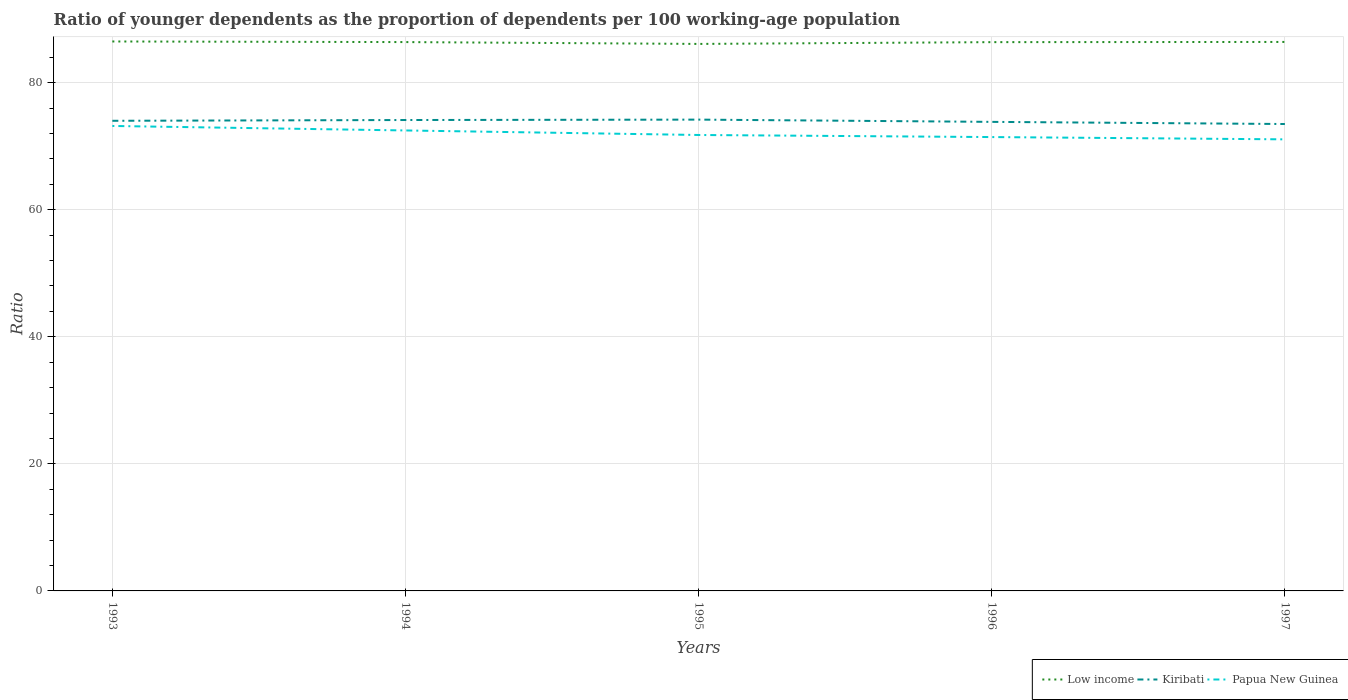Does the line corresponding to Papua New Guinea intersect with the line corresponding to Low income?
Give a very brief answer. No. Across all years, what is the maximum age dependency ratio(young) in Low income?
Make the answer very short. 86.1. What is the total age dependency ratio(young) in Low income in the graph?
Provide a short and direct response. 0.39. What is the difference between the highest and the second highest age dependency ratio(young) in Low income?
Your response must be concise. 0.39. What is the difference between the highest and the lowest age dependency ratio(young) in Kiribati?
Your answer should be very brief. 3. How many lines are there?
Ensure brevity in your answer.  3. How many years are there in the graph?
Make the answer very short. 5. What is the difference between two consecutive major ticks on the Y-axis?
Make the answer very short. 20. Are the values on the major ticks of Y-axis written in scientific E-notation?
Keep it short and to the point. No. Does the graph contain any zero values?
Your answer should be compact. No. Does the graph contain grids?
Your response must be concise. Yes. Where does the legend appear in the graph?
Ensure brevity in your answer.  Bottom right. How many legend labels are there?
Make the answer very short. 3. What is the title of the graph?
Your response must be concise. Ratio of younger dependents as the proportion of dependents per 100 working-age population. What is the label or title of the X-axis?
Make the answer very short. Years. What is the label or title of the Y-axis?
Your response must be concise. Ratio. What is the Ratio in Low income in 1993?
Offer a terse response. 86.49. What is the Ratio of Kiribati in 1993?
Provide a short and direct response. 74. What is the Ratio of Papua New Guinea in 1993?
Your answer should be very brief. 73.19. What is the Ratio in Low income in 1994?
Offer a very short reply. 86.39. What is the Ratio in Kiribati in 1994?
Offer a very short reply. 74.12. What is the Ratio of Papua New Guinea in 1994?
Ensure brevity in your answer.  72.48. What is the Ratio of Low income in 1995?
Your response must be concise. 86.1. What is the Ratio of Kiribati in 1995?
Offer a terse response. 74.19. What is the Ratio in Papua New Guinea in 1995?
Your response must be concise. 71.77. What is the Ratio of Low income in 1996?
Offer a terse response. 86.38. What is the Ratio in Kiribati in 1996?
Give a very brief answer. 73.83. What is the Ratio in Papua New Guinea in 1996?
Keep it short and to the point. 71.44. What is the Ratio in Low income in 1997?
Make the answer very short. 86.41. What is the Ratio of Kiribati in 1997?
Offer a terse response. 73.49. What is the Ratio of Papua New Guinea in 1997?
Offer a terse response. 71.08. Across all years, what is the maximum Ratio of Low income?
Provide a succinct answer. 86.49. Across all years, what is the maximum Ratio in Kiribati?
Offer a very short reply. 74.19. Across all years, what is the maximum Ratio in Papua New Guinea?
Offer a terse response. 73.19. Across all years, what is the minimum Ratio in Low income?
Give a very brief answer. 86.1. Across all years, what is the minimum Ratio of Kiribati?
Offer a very short reply. 73.49. Across all years, what is the minimum Ratio in Papua New Guinea?
Your response must be concise. 71.08. What is the total Ratio in Low income in the graph?
Offer a very short reply. 431.78. What is the total Ratio in Kiribati in the graph?
Your response must be concise. 369.64. What is the total Ratio in Papua New Guinea in the graph?
Your answer should be very brief. 359.96. What is the difference between the Ratio of Low income in 1993 and that in 1994?
Keep it short and to the point. 0.1. What is the difference between the Ratio of Kiribati in 1993 and that in 1994?
Your answer should be very brief. -0.12. What is the difference between the Ratio of Papua New Guinea in 1993 and that in 1994?
Keep it short and to the point. 0.71. What is the difference between the Ratio in Low income in 1993 and that in 1995?
Your answer should be very brief. 0.39. What is the difference between the Ratio of Kiribati in 1993 and that in 1995?
Keep it short and to the point. -0.19. What is the difference between the Ratio of Papua New Guinea in 1993 and that in 1995?
Ensure brevity in your answer.  1.42. What is the difference between the Ratio of Low income in 1993 and that in 1996?
Offer a terse response. 0.11. What is the difference between the Ratio in Kiribati in 1993 and that in 1996?
Give a very brief answer. 0.17. What is the difference between the Ratio of Papua New Guinea in 1993 and that in 1996?
Offer a very short reply. 1.75. What is the difference between the Ratio of Low income in 1993 and that in 1997?
Offer a terse response. 0.07. What is the difference between the Ratio in Kiribati in 1993 and that in 1997?
Your answer should be compact. 0.51. What is the difference between the Ratio of Papua New Guinea in 1993 and that in 1997?
Give a very brief answer. 2.11. What is the difference between the Ratio of Low income in 1994 and that in 1995?
Offer a very short reply. 0.29. What is the difference between the Ratio of Kiribati in 1994 and that in 1995?
Your answer should be compact. -0.06. What is the difference between the Ratio in Papua New Guinea in 1994 and that in 1995?
Ensure brevity in your answer.  0.71. What is the difference between the Ratio of Low income in 1994 and that in 1996?
Give a very brief answer. 0.01. What is the difference between the Ratio of Kiribati in 1994 and that in 1996?
Make the answer very short. 0.29. What is the difference between the Ratio of Papua New Guinea in 1994 and that in 1996?
Offer a terse response. 1.04. What is the difference between the Ratio in Low income in 1994 and that in 1997?
Make the answer very short. -0.02. What is the difference between the Ratio of Kiribati in 1994 and that in 1997?
Your answer should be very brief. 0.63. What is the difference between the Ratio of Papua New Guinea in 1994 and that in 1997?
Offer a terse response. 1.4. What is the difference between the Ratio of Low income in 1995 and that in 1996?
Keep it short and to the point. -0.28. What is the difference between the Ratio in Kiribati in 1995 and that in 1996?
Provide a short and direct response. 0.35. What is the difference between the Ratio of Papua New Guinea in 1995 and that in 1996?
Keep it short and to the point. 0.33. What is the difference between the Ratio in Low income in 1995 and that in 1997?
Your answer should be compact. -0.31. What is the difference between the Ratio in Kiribati in 1995 and that in 1997?
Your answer should be compact. 0.69. What is the difference between the Ratio in Papua New Guinea in 1995 and that in 1997?
Offer a very short reply. 0.69. What is the difference between the Ratio in Low income in 1996 and that in 1997?
Make the answer very short. -0.03. What is the difference between the Ratio of Kiribati in 1996 and that in 1997?
Your answer should be very brief. 0.34. What is the difference between the Ratio of Papua New Guinea in 1996 and that in 1997?
Make the answer very short. 0.36. What is the difference between the Ratio in Low income in 1993 and the Ratio in Kiribati in 1994?
Your response must be concise. 12.36. What is the difference between the Ratio in Low income in 1993 and the Ratio in Papua New Guinea in 1994?
Provide a succinct answer. 14.01. What is the difference between the Ratio in Kiribati in 1993 and the Ratio in Papua New Guinea in 1994?
Offer a terse response. 1.52. What is the difference between the Ratio of Low income in 1993 and the Ratio of Kiribati in 1995?
Provide a short and direct response. 12.3. What is the difference between the Ratio of Low income in 1993 and the Ratio of Papua New Guinea in 1995?
Your answer should be very brief. 14.72. What is the difference between the Ratio in Kiribati in 1993 and the Ratio in Papua New Guinea in 1995?
Make the answer very short. 2.23. What is the difference between the Ratio in Low income in 1993 and the Ratio in Kiribati in 1996?
Your answer should be very brief. 12.66. What is the difference between the Ratio of Low income in 1993 and the Ratio of Papua New Guinea in 1996?
Keep it short and to the point. 15.05. What is the difference between the Ratio of Kiribati in 1993 and the Ratio of Papua New Guinea in 1996?
Ensure brevity in your answer.  2.56. What is the difference between the Ratio of Low income in 1993 and the Ratio of Kiribati in 1997?
Offer a terse response. 12.99. What is the difference between the Ratio of Low income in 1993 and the Ratio of Papua New Guinea in 1997?
Provide a short and direct response. 15.41. What is the difference between the Ratio of Kiribati in 1993 and the Ratio of Papua New Guinea in 1997?
Your answer should be very brief. 2.92. What is the difference between the Ratio of Low income in 1994 and the Ratio of Kiribati in 1995?
Provide a short and direct response. 12.21. What is the difference between the Ratio of Low income in 1994 and the Ratio of Papua New Guinea in 1995?
Offer a very short reply. 14.62. What is the difference between the Ratio in Kiribati in 1994 and the Ratio in Papua New Guinea in 1995?
Your response must be concise. 2.36. What is the difference between the Ratio of Low income in 1994 and the Ratio of Kiribati in 1996?
Keep it short and to the point. 12.56. What is the difference between the Ratio in Low income in 1994 and the Ratio in Papua New Guinea in 1996?
Give a very brief answer. 14.95. What is the difference between the Ratio of Kiribati in 1994 and the Ratio of Papua New Guinea in 1996?
Your answer should be very brief. 2.68. What is the difference between the Ratio of Low income in 1994 and the Ratio of Kiribati in 1997?
Make the answer very short. 12.9. What is the difference between the Ratio in Low income in 1994 and the Ratio in Papua New Guinea in 1997?
Offer a terse response. 15.31. What is the difference between the Ratio of Kiribati in 1994 and the Ratio of Papua New Guinea in 1997?
Your answer should be compact. 3.04. What is the difference between the Ratio in Low income in 1995 and the Ratio in Kiribati in 1996?
Make the answer very short. 12.27. What is the difference between the Ratio of Low income in 1995 and the Ratio of Papua New Guinea in 1996?
Your answer should be very brief. 14.66. What is the difference between the Ratio in Kiribati in 1995 and the Ratio in Papua New Guinea in 1996?
Offer a very short reply. 2.75. What is the difference between the Ratio in Low income in 1995 and the Ratio in Kiribati in 1997?
Keep it short and to the point. 12.61. What is the difference between the Ratio of Low income in 1995 and the Ratio of Papua New Guinea in 1997?
Your answer should be compact. 15.02. What is the difference between the Ratio of Kiribati in 1995 and the Ratio of Papua New Guinea in 1997?
Offer a very short reply. 3.11. What is the difference between the Ratio of Low income in 1996 and the Ratio of Kiribati in 1997?
Provide a short and direct response. 12.89. What is the difference between the Ratio in Low income in 1996 and the Ratio in Papua New Guinea in 1997?
Your answer should be very brief. 15.3. What is the difference between the Ratio in Kiribati in 1996 and the Ratio in Papua New Guinea in 1997?
Make the answer very short. 2.75. What is the average Ratio in Low income per year?
Your answer should be compact. 86.36. What is the average Ratio of Kiribati per year?
Your answer should be very brief. 73.93. What is the average Ratio of Papua New Guinea per year?
Your answer should be compact. 71.99. In the year 1993, what is the difference between the Ratio in Low income and Ratio in Kiribati?
Give a very brief answer. 12.49. In the year 1993, what is the difference between the Ratio of Low income and Ratio of Papua New Guinea?
Give a very brief answer. 13.3. In the year 1993, what is the difference between the Ratio of Kiribati and Ratio of Papua New Guinea?
Make the answer very short. 0.81. In the year 1994, what is the difference between the Ratio of Low income and Ratio of Kiribati?
Offer a terse response. 12.27. In the year 1994, what is the difference between the Ratio in Low income and Ratio in Papua New Guinea?
Provide a short and direct response. 13.91. In the year 1994, what is the difference between the Ratio of Kiribati and Ratio of Papua New Guinea?
Ensure brevity in your answer.  1.64. In the year 1995, what is the difference between the Ratio of Low income and Ratio of Kiribati?
Your response must be concise. 11.91. In the year 1995, what is the difference between the Ratio of Low income and Ratio of Papua New Guinea?
Offer a terse response. 14.33. In the year 1995, what is the difference between the Ratio in Kiribati and Ratio in Papua New Guinea?
Your answer should be compact. 2.42. In the year 1996, what is the difference between the Ratio in Low income and Ratio in Kiribati?
Your answer should be compact. 12.55. In the year 1996, what is the difference between the Ratio of Low income and Ratio of Papua New Guinea?
Your answer should be very brief. 14.94. In the year 1996, what is the difference between the Ratio of Kiribati and Ratio of Papua New Guinea?
Offer a very short reply. 2.39. In the year 1997, what is the difference between the Ratio in Low income and Ratio in Kiribati?
Offer a terse response. 12.92. In the year 1997, what is the difference between the Ratio in Low income and Ratio in Papua New Guinea?
Your answer should be compact. 15.33. In the year 1997, what is the difference between the Ratio in Kiribati and Ratio in Papua New Guinea?
Make the answer very short. 2.41. What is the ratio of the Ratio in Low income in 1993 to that in 1994?
Give a very brief answer. 1. What is the ratio of the Ratio of Papua New Guinea in 1993 to that in 1994?
Keep it short and to the point. 1.01. What is the ratio of the Ratio in Low income in 1993 to that in 1995?
Your response must be concise. 1. What is the ratio of the Ratio of Papua New Guinea in 1993 to that in 1995?
Provide a short and direct response. 1.02. What is the ratio of the Ratio in Papua New Guinea in 1993 to that in 1996?
Ensure brevity in your answer.  1.02. What is the ratio of the Ratio of Kiribati in 1993 to that in 1997?
Provide a succinct answer. 1.01. What is the ratio of the Ratio in Papua New Guinea in 1993 to that in 1997?
Your answer should be compact. 1.03. What is the ratio of the Ratio in Low income in 1994 to that in 1995?
Your answer should be compact. 1. What is the ratio of the Ratio in Kiribati in 1994 to that in 1995?
Your response must be concise. 1. What is the ratio of the Ratio of Papua New Guinea in 1994 to that in 1995?
Your answer should be compact. 1.01. What is the ratio of the Ratio of Low income in 1994 to that in 1996?
Provide a short and direct response. 1. What is the ratio of the Ratio of Papua New Guinea in 1994 to that in 1996?
Your response must be concise. 1.01. What is the ratio of the Ratio in Kiribati in 1994 to that in 1997?
Your answer should be very brief. 1.01. What is the ratio of the Ratio of Papua New Guinea in 1994 to that in 1997?
Ensure brevity in your answer.  1.02. What is the ratio of the Ratio in Low income in 1995 to that in 1996?
Give a very brief answer. 1. What is the ratio of the Ratio in Kiribati in 1995 to that in 1996?
Provide a succinct answer. 1. What is the ratio of the Ratio in Papua New Guinea in 1995 to that in 1996?
Give a very brief answer. 1. What is the ratio of the Ratio in Low income in 1995 to that in 1997?
Ensure brevity in your answer.  1. What is the ratio of the Ratio of Kiribati in 1995 to that in 1997?
Provide a short and direct response. 1.01. What is the ratio of the Ratio in Papua New Guinea in 1995 to that in 1997?
Ensure brevity in your answer.  1.01. What is the ratio of the Ratio in Low income in 1996 to that in 1997?
Make the answer very short. 1. What is the difference between the highest and the second highest Ratio of Low income?
Your answer should be very brief. 0.07. What is the difference between the highest and the second highest Ratio in Kiribati?
Your response must be concise. 0.06. What is the difference between the highest and the second highest Ratio in Papua New Guinea?
Your answer should be very brief. 0.71. What is the difference between the highest and the lowest Ratio in Low income?
Keep it short and to the point. 0.39. What is the difference between the highest and the lowest Ratio of Kiribati?
Make the answer very short. 0.69. What is the difference between the highest and the lowest Ratio in Papua New Guinea?
Your answer should be compact. 2.11. 